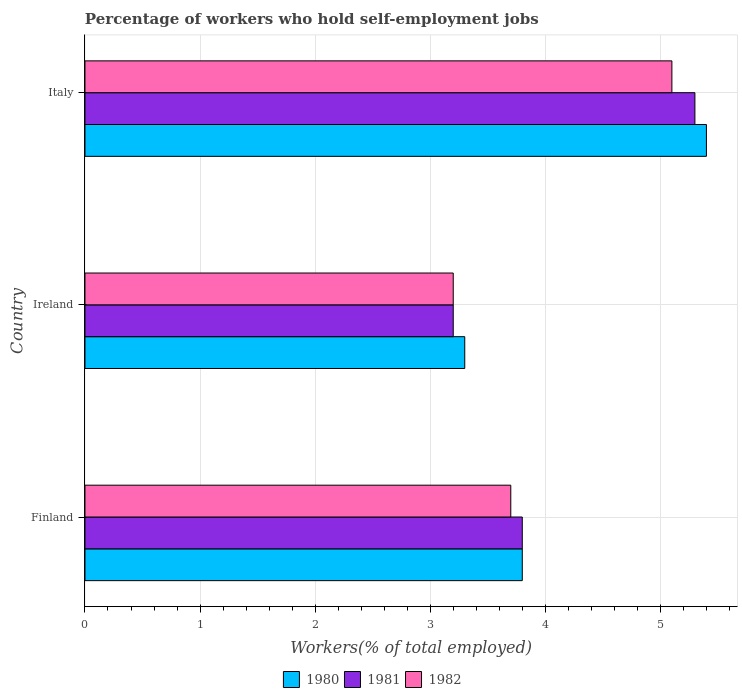Are the number of bars on each tick of the Y-axis equal?
Give a very brief answer. Yes. How many bars are there on the 2nd tick from the top?
Make the answer very short. 3. How many bars are there on the 2nd tick from the bottom?
Ensure brevity in your answer.  3. What is the label of the 1st group of bars from the top?
Offer a terse response. Italy. In how many cases, is the number of bars for a given country not equal to the number of legend labels?
Offer a very short reply. 0. What is the percentage of self-employed workers in 1980 in Finland?
Provide a short and direct response. 3.8. Across all countries, what is the maximum percentage of self-employed workers in 1981?
Give a very brief answer. 5.3. Across all countries, what is the minimum percentage of self-employed workers in 1981?
Offer a very short reply. 3.2. In which country was the percentage of self-employed workers in 1982 maximum?
Give a very brief answer. Italy. In which country was the percentage of self-employed workers in 1980 minimum?
Ensure brevity in your answer.  Ireland. What is the total percentage of self-employed workers in 1980 in the graph?
Give a very brief answer. 12.5. What is the difference between the percentage of self-employed workers in 1981 in Finland and that in Ireland?
Your answer should be compact. 0.6. What is the difference between the percentage of self-employed workers in 1980 in Italy and the percentage of self-employed workers in 1982 in Finland?
Your answer should be very brief. 1.7. What is the average percentage of self-employed workers in 1980 per country?
Your answer should be compact. 4.17. What is the difference between the percentage of self-employed workers in 1981 and percentage of self-employed workers in 1980 in Ireland?
Ensure brevity in your answer.  -0.1. What is the ratio of the percentage of self-employed workers in 1982 in Finland to that in Ireland?
Your answer should be compact. 1.16. What is the difference between the highest and the second highest percentage of self-employed workers in 1980?
Ensure brevity in your answer.  1.6. What is the difference between the highest and the lowest percentage of self-employed workers in 1981?
Your answer should be very brief. 2.1. In how many countries, is the percentage of self-employed workers in 1981 greater than the average percentage of self-employed workers in 1981 taken over all countries?
Provide a succinct answer. 1. Is the sum of the percentage of self-employed workers in 1980 in Finland and Ireland greater than the maximum percentage of self-employed workers in 1981 across all countries?
Your response must be concise. Yes. What does the 1st bar from the top in Ireland represents?
Provide a short and direct response. 1982. Is it the case that in every country, the sum of the percentage of self-employed workers in 1980 and percentage of self-employed workers in 1982 is greater than the percentage of self-employed workers in 1981?
Your answer should be compact. Yes. How many bars are there?
Provide a succinct answer. 9. Are all the bars in the graph horizontal?
Your response must be concise. Yes. Are the values on the major ticks of X-axis written in scientific E-notation?
Make the answer very short. No. Does the graph contain grids?
Provide a short and direct response. Yes. How many legend labels are there?
Provide a short and direct response. 3. How are the legend labels stacked?
Make the answer very short. Horizontal. What is the title of the graph?
Offer a very short reply. Percentage of workers who hold self-employment jobs. Does "2015" appear as one of the legend labels in the graph?
Provide a short and direct response. No. What is the label or title of the X-axis?
Provide a succinct answer. Workers(% of total employed). What is the label or title of the Y-axis?
Make the answer very short. Country. What is the Workers(% of total employed) in 1980 in Finland?
Your answer should be compact. 3.8. What is the Workers(% of total employed) in 1981 in Finland?
Your answer should be very brief. 3.8. What is the Workers(% of total employed) in 1982 in Finland?
Provide a succinct answer. 3.7. What is the Workers(% of total employed) in 1980 in Ireland?
Make the answer very short. 3.3. What is the Workers(% of total employed) in 1981 in Ireland?
Keep it short and to the point. 3.2. What is the Workers(% of total employed) in 1982 in Ireland?
Provide a succinct answer. 3.2. What is the Workers(% of total employed) of 1980 in Italy?
Provide a short and direct response. 5.4. What is the Workers(% of total employed) of 1981 in Italy?
Ensure brevity in your answer.  5.3. What is the Workers(% of total employed) of 1982 in Italy?
Your response must be concise. 5.1. Across all countries, what is the maximum Workers(% of total employed) of 1980?
Provide a short and direct response. 5.4. Across all countries, what is the maximum Workers(% of total employed) of 1981?
Offer a very short reply. 5.3. Across all countries, what is the maximum Workers(% of total employed) of 1982?
Your answer should be very brief. 5.1. Across all countries, what is the minimum Workers(% of total employed) in 1980?
Give a very brief answer. 3.3. Across all countries, what is the minimum Workers(% of total employed) of 1981?
Your answer should be very brief. 3.2. Across all countries, what is the minimum Workers(% of total employed) of 1982?
Make the answer very short. 3.2. What is the total Workers(% of total employed) in 1982 in the graph?
Ensure brevity in your answer.  12. What is the difference between the Workers(% of total employed) in 1980 in Finland and that in Ireland?
Give a very brief answer. 0.5. What is the difference between the Workers(% of total employed) of 1981 in Finland and that in Italy?
Your answer should be very brief. -1.5. What is the difference between the Workers(% of total employed) in 1982 in Finland and that in Italy?
Your response must be concise. -1.4. What is the difference between the Workers(% of total employed) of 1982 in Ireland and that in Italy?
Make the answer very short. -1.9. What is the difference between the Workers(% of total employed) in 1980 in Finland and the Workers(% of total employed) in 1981 in Ireland?
Your answer should be very brief. 0.6. What is the difference between the Workers(% of total employed) in 1980 in Finland and the Workers(% of total employed) in 1982 in Ireland?
Ensure brevity in your answer.  0.6. What is the difference between the Workers(% of total employed) of 1981 in Finland and the Workers(% of total employed) of 1982 in Ireland?
Give a very brief answer. 0.6. What is the average Workers(% of total employed) in 1980 per country?
Provide a short and direct response. 4.17. What is the average Workers(% of total employed) in 1981 per country?
Your answer should be compact. 4.1. What is the average Workers(% of total employed) of 1982 per country?
Make the answer very short. 4. What is the difference between the Workers(% of total employed) of 1980 and Workers(% of total employed) of 1981 in Finland?
Your answer should be very brief. 0. What is the difference between the Workers(% of total employed) of 1980 and Workers(% of total employed) of 1982 in Finland?
Ensure brevity in your answer.  0.1. What is the difference between the Workers(% of total employed) in 1981 and Workers(% of total employed) in 1982 in Finland?
Ensure brevity in your answer.  0.1. What is the difference between the Workers(% of total employed) in 1980 and Workers(% of total employed) in 1982 in Ireland?
Your answer should be compact. 0.1. What is the difference between the Workers(% of total employed) in 1980 and Workers(% of total employed) in 1981 in Italy?
Your response must be concise. 0.1. What is the difference between the Workers(% of total employed) in 1981 and Workers(% of total employed) in 1982 in Italy?
Offer a terse response. 0.2. What is the ratio of the Workers(% of total employed) in 1980 in Finland to that in Ireland?
Keep it short and to the point. 1.15. What is the ratio of the Workers(% of total employed) of 1981 in Finland to that in Ireland?
Give a very brief answer. 1.19. What is the ratio of the Workers(% of total employed) of 1982 in Finland to that in Ireland?
Make the answer very short. 1.16. What is the ratio of the Workers(% of total employed) of 1980 in Finland to that in Italy?
Your response must be concise. 0.7. What is the ratio of the Workers(% of total employed) in 1981 in Finland to that in Italy?
Your answer should be very brief. 0.72. What is the ratio of the Workers(% of total employed) in 1982 in Finland to that in Italy?
Your answer should be very brief. 0.73. What is the ratio of the Workers(% of total employed) in 1980 in Ireland to that in Italy?
Provide a succinct answer. 0.61. What is the ratio of the Workers(% of total employed) in 1981 in Ireland to that in Italy?
Your answer should be compact. 0.6. What is the ratio of the Workers(% of total employed) in 1982 in Ireland to that in Italy?
Give a very brief answer. 0.63. What is the difference between the highest and the second highest Workers(% of total employed) of 1980?
Provide a short and direct response. 1.6. What is the difference between the highest and the second highest Workers(% of total employed) of 1982?
Offer a terse response. 1.4. What is the difference between the highest and the lowest Workers(% of total employed) of 1981?
Provide a succinct answer. 2.1. 